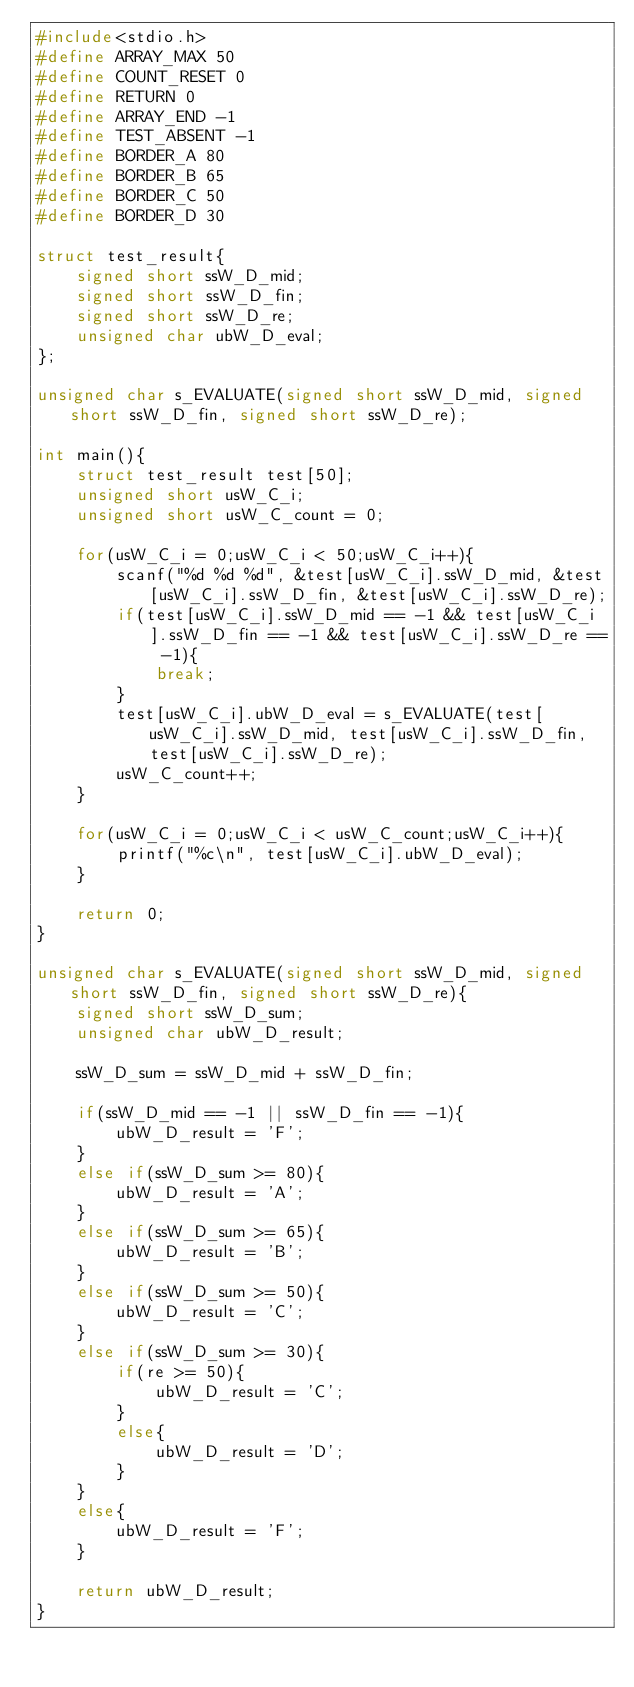<code> <loc_0><loc_0><loc_500><loc_500><_C_>#include<stdio.h>
#define ARRAY_MAX 50
#define COUNT_RESET 0
#define RETURN 0
#define ARRAY_END -1
#define TEST_ABSENT -1
#define BORDER_A 80
#define BORDER_B 65
#define BORDER_C 50
#define BORDER_D 30

struct test_result{
    signed short ssW_D_mid;
    signed short ssW_D_fin;
    signed short ssW_D_re;
    unsigned char ubW_D_eval;
};

unsigned char s_EVALUATE(signed short ssW_D_mid, signed short ssW_D_fin, signed short ssW_D_re);

int main(){
    struct test_result test[50];
    unsigned short usW_C_i;
    unsigned short usW_C_count = 0;

    for(usW_C_i = 0;usW_C_i < 50;usW_C_i++){
        scanf("%d %d %d", &test[usW_C_i].ssW_D_mid, &test[usW_C_i].ssW_D_fin, &test[usW_C_i].ssW_D_re);
        if(test[usW_C_i].ssW_D_mid == -1 && test[usW_C_i].ssW_D_fin == -1 && test[usW_C_i].ssW_D_re == -1){
            break;
        }
        test[usW_C_i].ubW_D_eval = s_EVALUATE(test[usW_C_i].ssW_D_mid, test[usW_C_i].ssW_D_fin, test[usW_C_i].ssW_D_re);
        usW_C_count++;
    }

    for(usW_C_i = 0;usW_C_i < usW_C_count;usW_C_i++){
        printf("%c\n", test[usW_C_i].ubW_D_eval);
    }

    return 0;
}

unsigned char s_EVALUATE(signed short ssW_D_mid, signed short ssW_D_fin, signed short ssW_D_re){
    signed short ssW_D_sum;
    unsigned char ubW_D_result;

    ssW_D_sum = ssW_D_mid + ssW_D_fin;

    if(ssW_D_mid == -1 || ssW_D_fin == -1){
        ubW_D_result = 'F';
    }
    else if(ssW_D_sum >= 80){
        ubW_D_result = 'A';
    }
    else if(ssW_D_sum >= 65){
        ubW_D_result = 'B';
    }
    else if(ssW_D_sum >= 50){
        ubW_D_result = 'C';
    }
    else if(ssW_D_sum >= 30){
        if(re >= 50){
            ubW_D_result = 'C';
        }
        else{
            ubW_D_result = 'D';
        }
    }
    else{
        ubW_D_result = 'F';
    }

    return ubW_D_result;
}
</code> 